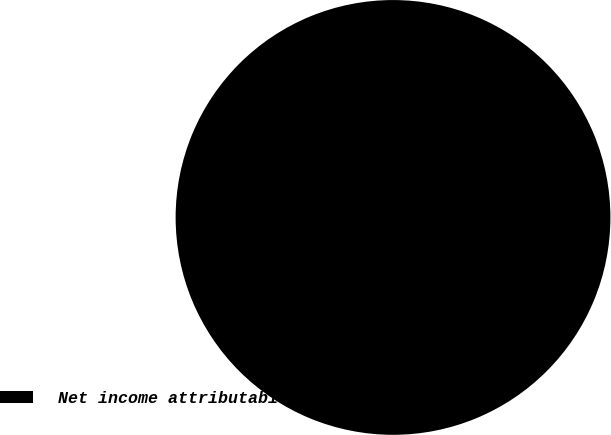Convert chart to OTSL. <chart><loc_0><loc_0><loc_500><loc_500><pie_chart><fcel>Net income attributable to<nl><fcel>100.0%<nl></chart> 